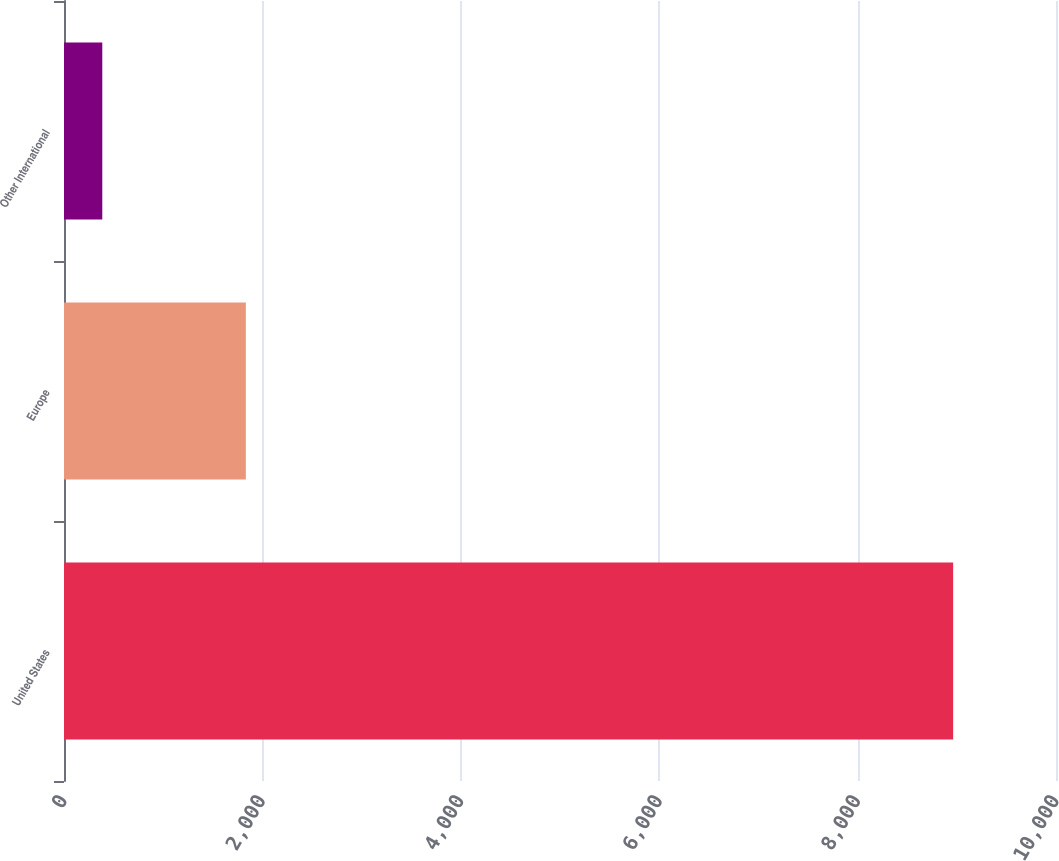Convert chart. <chart><loc_0><loc_0><loc_500><loc_500><bar_chart><fcel>United States<fcel>Europe<fcel>Other International<nl><fcel>8963<fcel>1833<fcel>386<nl></chart> 